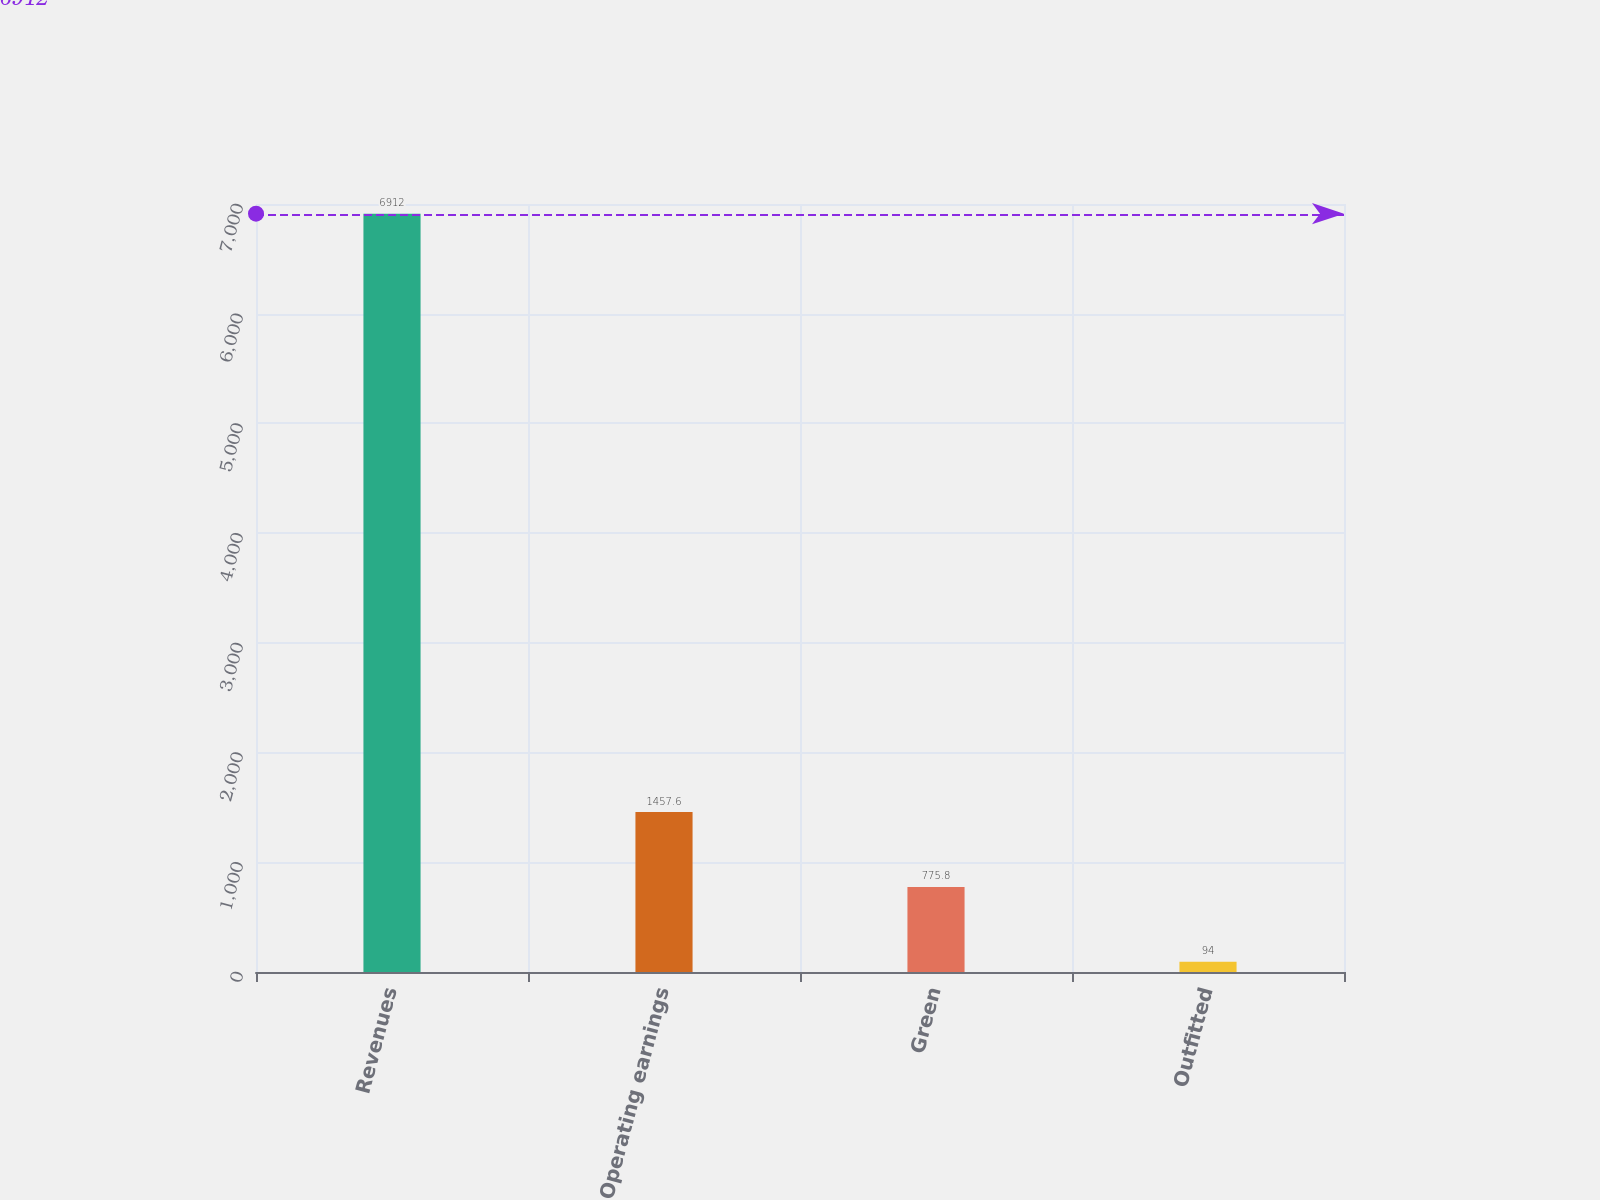<chart> <loc_0><loc_0><loc_500><loc_500><bar_chart><fcel>Revenues<fcel>Operating earnings<fcel>Green<fcel>Outfitted<nl><fcel>6912<fcel>1457.6<fcel>775.8<fcel>94<nl></chart> 